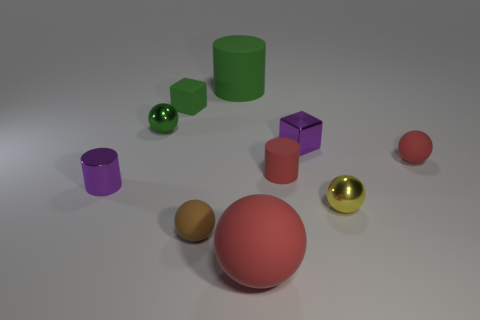Subtract all yellow balls. How many balls are left? 4 Subtract all large rubber spheres. How many spheres are left? 4 Subtract all cyan balls. Subtract all purple cylinders. How many balls are left? 5 Subtract all cylinders. How many objects are left? 7 Subtract 0 brown cubes. How many objects are left? 10 Subtract all small brown spheres. Subtract all large rubber cylinders. How many objects are left? 8 Add 4 balls. How many balls are left? 9 Add 3 small gray matte spheres. How many small gray matte spheres exist? 3 